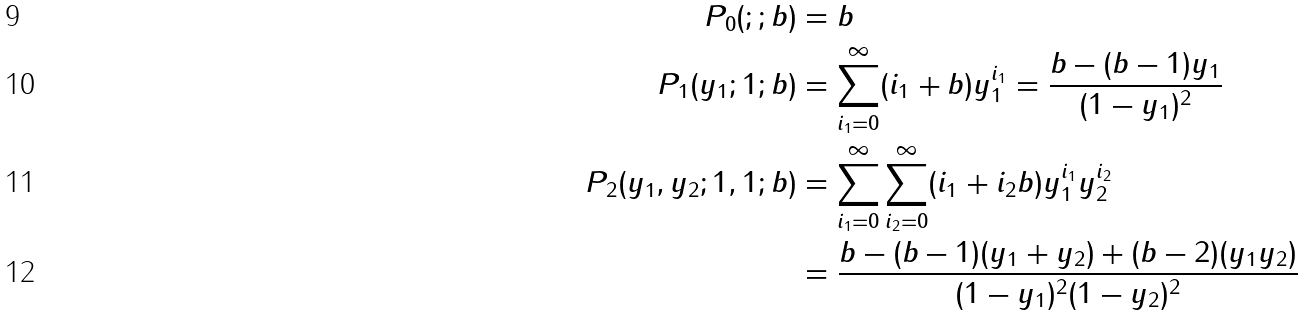<formula> <loc_0><loc_0><loc_500><loc_500>P _ { 0 } ( ; ; b ) & = b \\ P _ { 1 } ( y _ { 1 } ; 1 ; b ) & = \sum _ { i _ { 1 } = 0 } ^ { \infty } ( i _ { 1 } + b ) y _ { 1 } ^ { i _ { 1 } } = \frac { b - ( b - 1 ) y _ { 1 } } { ( 1 - y _ { 1 } ) ^ { 2 } } \\ P _ { 2 } ( y _ { 1 } , y _ { 2 } ; 1 , 1 ; b ) & = \sum _ { i _ { 1 } = 0 } ^ { \infty } \sum _ { i _ { 2 } = 0 } ^ { \infty } ( i _ { 1 } + i _ { 2 } b ) y _ { 1 } ^ { i _ { 1 } } y _ { 2 } ^ { i _ { 2 } } \\ & = \frac { b - ( b - 1 ) ( y _ { 1 } + y _ { 2 } ) + ( b - 2 ) ( y _ { 1 } y _ { 2 } ) } { ( 1 - y _ { 1 } ) ^ { 2 } ( 1 - y _ { 2 } ) ^ { 2 } }</formula> 